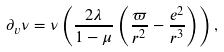Convert formula to latex. <formula><loc_0><loc_0><loc_500><loc_500>\partial _ { v } \nu = \nu \left ( \frac { 2 \lambda } { 1 - \mu } \left ( \frac { \varpi } { r ^ { 2 } } - \frac { e ^ { 2 } } { r ^ { 3 } } \right ) \right ) ,</formula> 